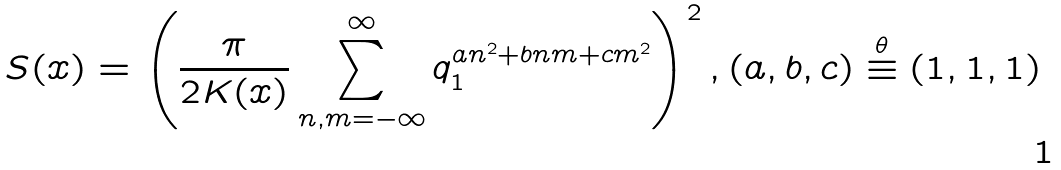Convert formula to latex. <formula><loc_0><loc_0><loc_500><loc_500>S ( x ) = \left ( \frac { \pi } { 2 K ( x ) } \sum ^ { \infty } _ { n , m = - \infty } q _ { 1 } ^ { a n ^ { 2 } + b n m + c m ^ { 2 } } \right ) ^ { 2 } , ( a , b , c ) \stackrel { \theta } { \equiv } ( 1 , 1 , 1 )</formula> 